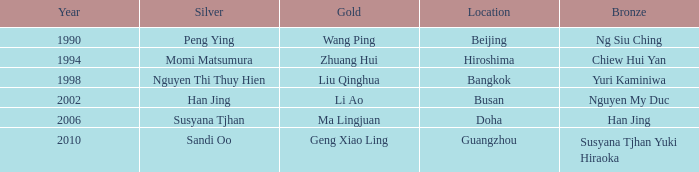What Gold has the Year of 1994? Zhuang Hui. 